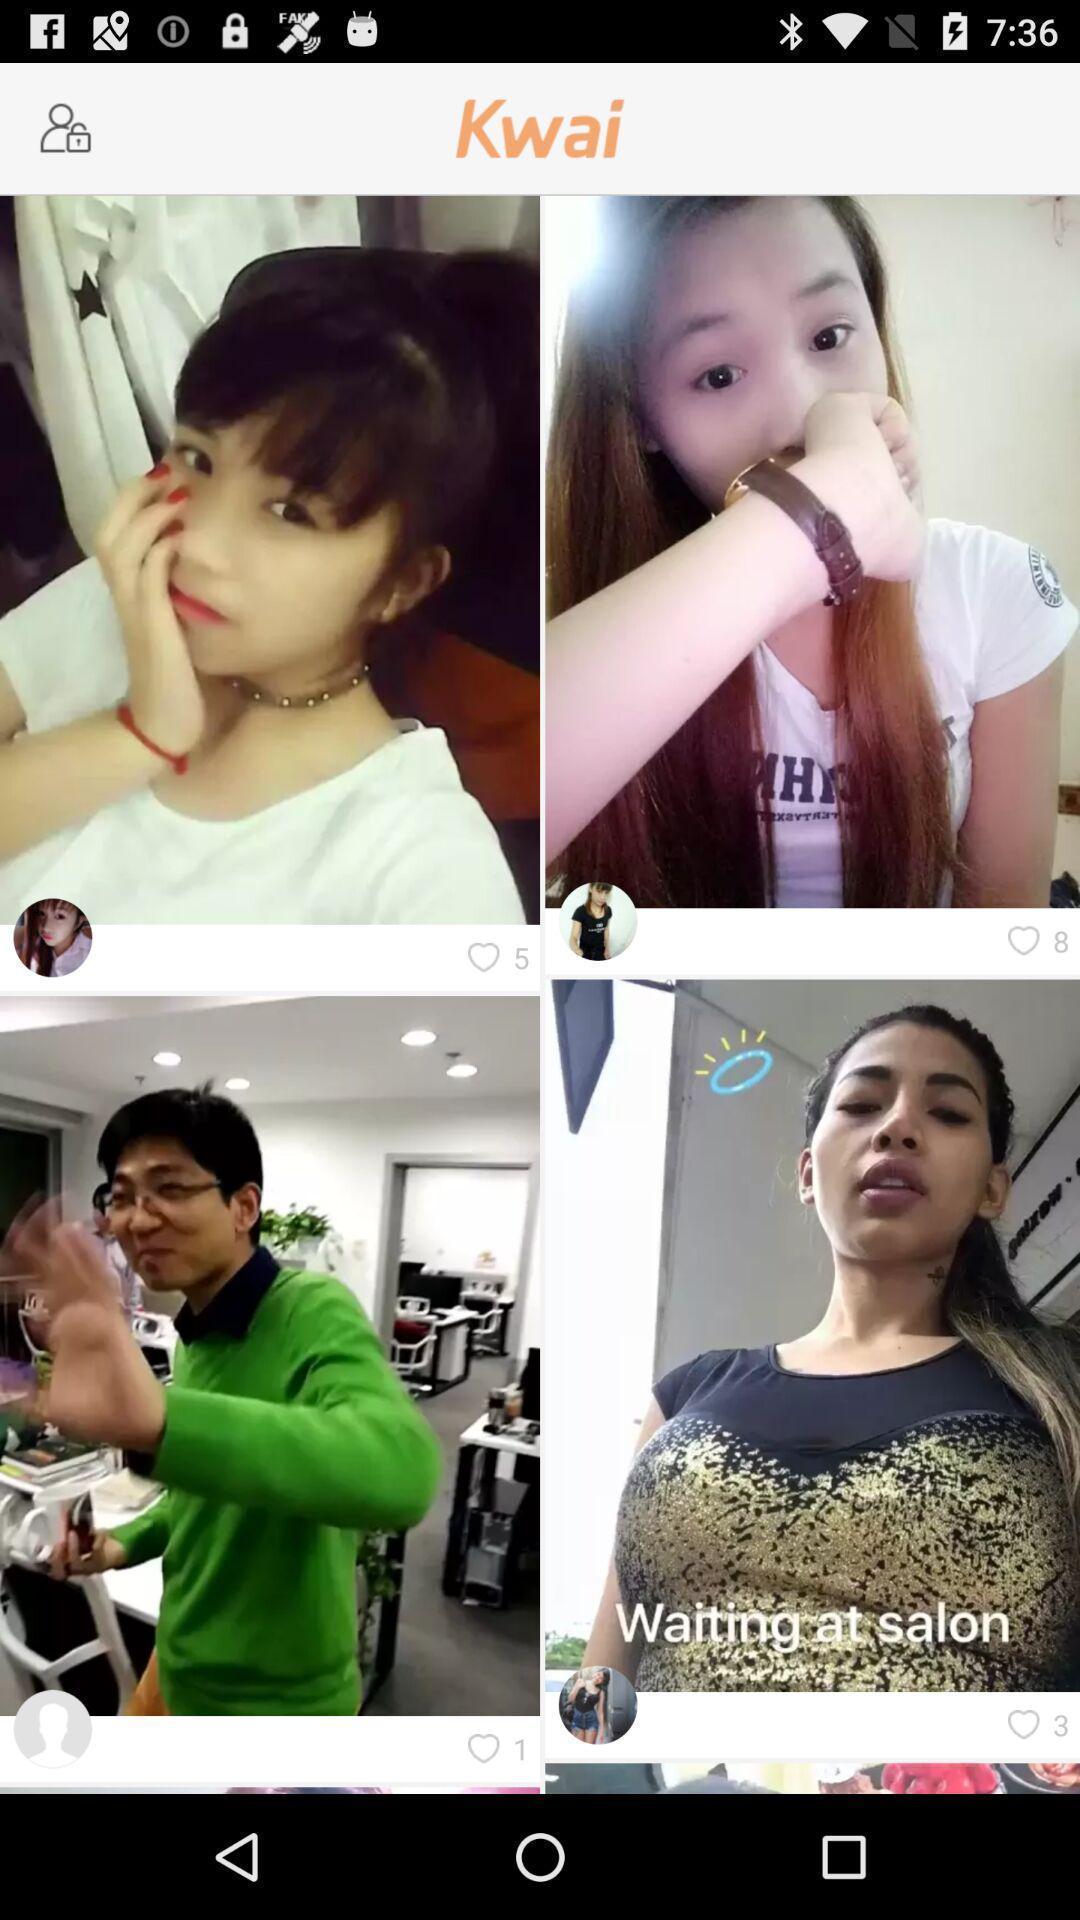Summarize the main components in this picture. Pictures page of a social app. 